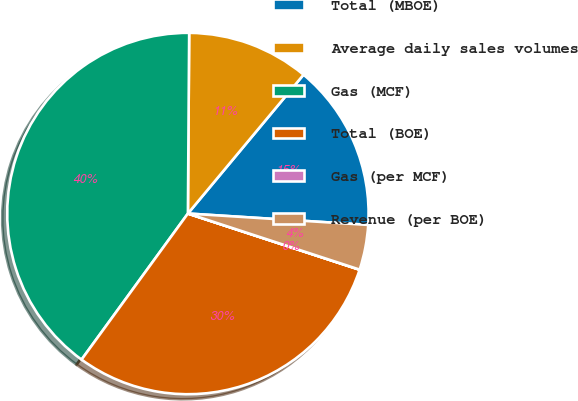<chart> <loc_0><loc_0><loc_500><loc_500><pie_chart><fcel>Total (MBOE)<fcel>Average daily sales volumes<fcel>Gas (MCF)<fcel>Total (BOE)<fcel>Gas (per MCF)<fcel>Revenue (per BOE)<nl><fcel>14.95%<fcel>10.94%<fcel>40.09%<fcel>29.98%<fcel>0.01%<fcel>4.02%<nl></chart> 